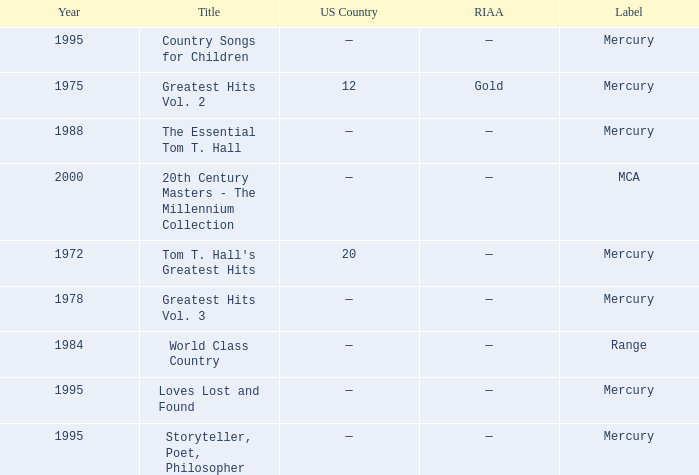What is the highest year for the title, "loves lost and found"? 1995.0. 